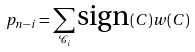Convert formula to latex. <formula><loc_0><loc_0><loc_500><loc_500>p _ { n - i } = \sum _ { \mathcal { C } _ { i } } \text {sign} ( C ) w ( C )</formula> 